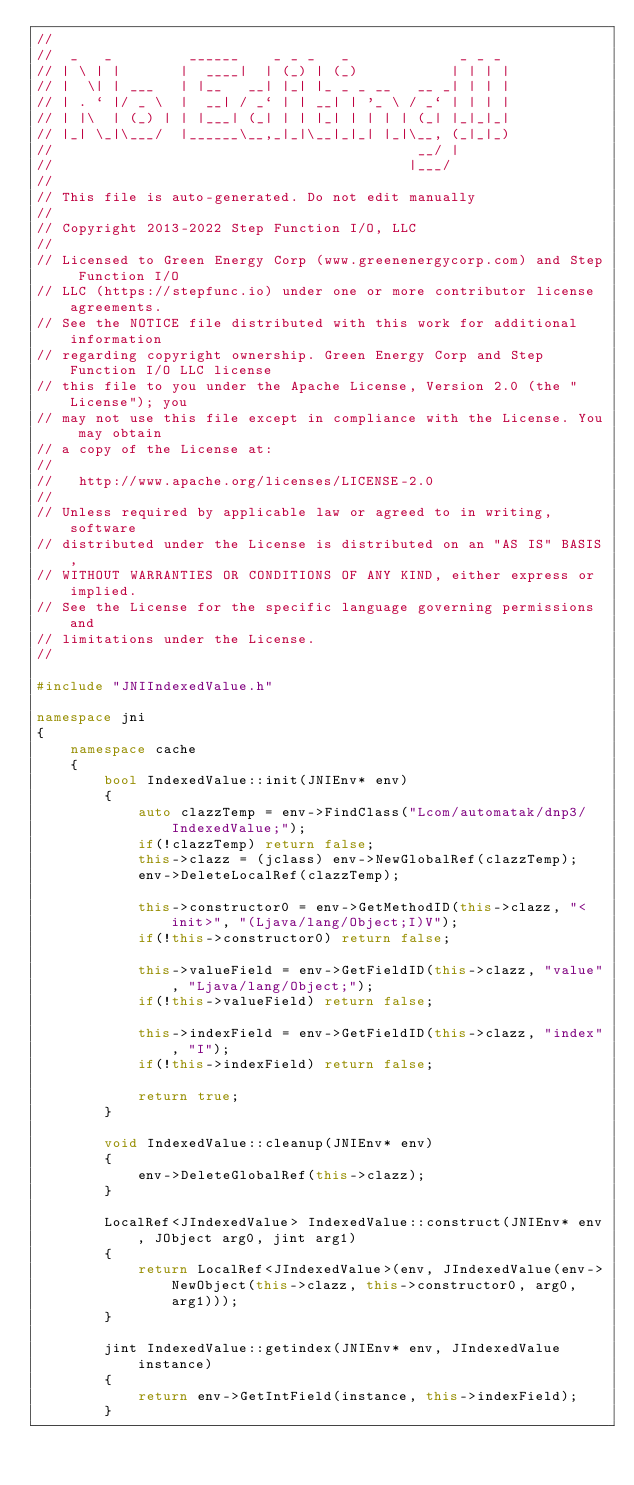<code> <loc_0><loc_0><loc_500><loc_500><_C++_>//
//  _   _         ______    _ _ _   _             _ _ _
// | \ | |       |  ____|  | (_) | (_)           | | | |
// |  \| | ___   | |__   __| |_| |_ _ _ __   __ _| | | |
// | . ` |/ _ \  |  __| / _` | | __| | '_ \ / _` | | | |
// | |\  | (_) | | |___| (_| | | |_| | | | | (_| |_|_|_|
// |_| \_|\___/  |______\__,_|_|\__|_|_| |_|\__, (_|_|_)
//                                           __/ |
//                                          |___/
// 
// This file is auto-generated. Do not edit manually
// 
// Copyright 2013-2022 Step Function I/O, LLC
// 
// Licensed to Green Energy Corp (www.greenenergycorp.com) and Step Function I/O
// LLC (https://stepfunc.io) under one or more contributor license agreements.
// See the NOTICE file distributed with this work for additional information
// regarding copyright ownership. Green Energy Corp and Step Function I/O LLC license
// this file to you under the Apache License, Version 2.0 (the "License"); you
// may not use this file except in compliance with the License. You may obtain
// a copy of the License at:
// 
//   http://www.apache.org/licenses/LICENSE-2.0
// 
// Unless required by applicable law or agreed to in writing, software
// distributed under the License is distributed on an "AS IS" BASIS,
// WITHOUT WARRANTIES OR CONDITIONS OF ANY KIND, either express or implied.
// See the License for the specific language governing permissions and
// limitations under the License.
//

#include "JNIIndexedValue.h"

namespace jni
{
    namespace cache
    {
        bool IndexedValue::init(JNIEnv* env)
        {
            auto clazzTemp = env->FindClass("Lcom/automatak/dnp3/IndexedValue;");
            if(!clazzTemp) return false;
            this->clazz = (jclass) env->NewGlobalRef(clazzTemp);
            env->DeleteLocalRef(clazzTemp);

            this->constructor0 = env->GetMethodID(this->clazz, "<init>", "(Ljava/lang/Object;I)V");
            if(!this->constructor0) return false;

            this->valueField = env->GetFieldID(this->clazz, "value", "Ljava/lang/Object;");
            if(!this->valueField) return false;

            this->indexField = env->GetFieldID(this->clazz, "index", "I");
            if(!this->indexField) return false;

            return true;
        }

        void IndexedValue::cleanup(JNIEnv* env)
        {
            env->DeleteGlobalRef(this->clazz);
        }

        LocalRef<JIndexedValue> IndexedValue::construct(JNIEnv* env, JObject arg0, jint arg1)
        {
            return LocalRef<JIndexedValue>(env, JIndexedValue(env->NewObject(this->clazz, this->constructor0, arg0, arg1)));
        }

        jint IndexedValue::getindex(JNIEnv* env, JIndexedValue instance)
        {
            return env->GetIntField(instance, this->indexField);
        }
</code> 